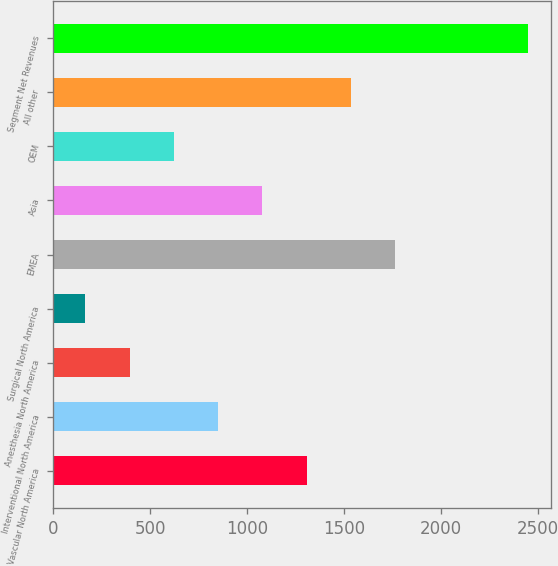Convert chart. <chart><loc_0><loc_0><loc_500><loc_500><bar_chart><fcel>Vascular North America<fcel>Interventional North America<fcel>Anesthesia North America<fcel>Surgical North America<fcel>EMEA<fcel>Asia<fcel>OEM<fcel>All other<fcel>Segment Net Revenues<nl><fcel>1307.35<fcel>850.93<fcel>394.51<fcel>166.3<fcel>1763.77<fcel>1079.14<fcel>622.72<fcel>1535.56<fcel>2448.4<nl></chart> 